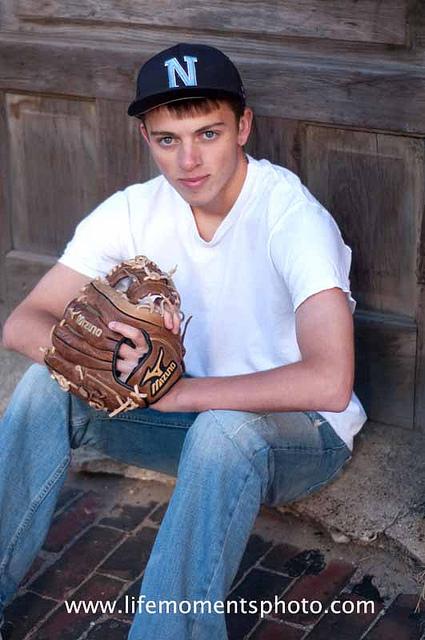Is the boy left or right handed?
Short answer required. Right. What letter is on the boy's cap?
Concise answer only. N. Is the boy a baseball player?
Write a very short answer. Yes. Do you see a garden?
Give a very brief answer. No. 